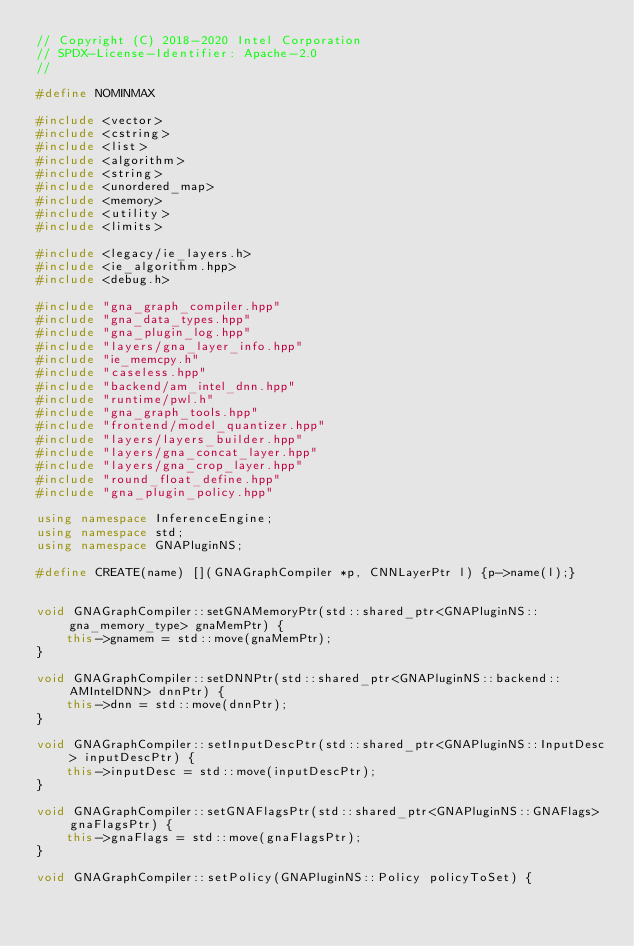<code> <loc_0><loc_0><loc_500><loc_500><_C++_>// Copyright (C) 2018-2020 Intel Corporation
// SPDX-License-Identifier: Apache-2.0
//

#define NOMINMAX

#include <vector>
#include <cstring>
#include <list>
#include <algorithm>
#include <string>
#include <unordered_map>
#include <memory>
#include <utility>
#include <limits>

#include <legacy/ie_layers.h>
#include <ie_algorithm.hpp>
#include <debug.h>

#include "gna_graph_compiler.hpp"
#include "gna_data_types.hpp"
#include "gna_plugin_log.hpp"
#include "layers/gna_layer_info.hpp"
#include "ie_memcpy.h"
#include "caseless.hpp"
#include "backend/am_intel_dnn.hpp"
#include "runtime/pwl.h"
#include "gna_graph_tools.hpp"
#include "frontend/model_quantizer.hpp"
#include "layers/layers_builder.hpp"
#include "layers/gna_concat_layer.hpp"
#include "layers/gna_crop_layer.hpp"
#include "round_float_define.hpp"
#include "gna_plugin_policy.hpp"

using namespace InferenceEngine;
using namespace std;
using namespace GNAPluginNS;

#define CREATE(name) [](GNAGraphCompiler *p, CNNLayerPtr l) {p->name(l);}


void GNAGraphCompiler::setGNAMemoryPtr(std::shared_ptr<GNAPluginNS::gna_memory_type> gnaMemPtr) {
    this->gnamem = std::move(gnaMemPtr);
}

void GNAGraphCompiler::setDNNPtr(std::shared_ptr<GNAPluginNS::backend::AMIntelDNN> dnnPtr) {
    this->dnn = std::move(dnnPtr);
}

void GNAGraphCompiler::setInputDescPtr(std::shared_ptr<GNAPluginNS::InputDesc> inputDescPtr) {
    this->inputDesc = std::move(inputDescPtr);
}

void GNAGraphCompiler::setGNAFlagsPtr(std::shared_ptr<GNAPluginNS::GNAFlags> gnaFlagsPtr) {
    this->gnaFlags = std::move(gnaFlagsPtr);
}

void GNAGraphCompiler::setPolicy(GNAPluginNS::Policy policyToSet) {</code> 